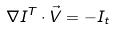Convert formula to latex. <formula><loc_0><loc_0><loc_500><loc_500>\nabla I ^ { T } \cdot \vec { V } = - I _ { t }</formula> 